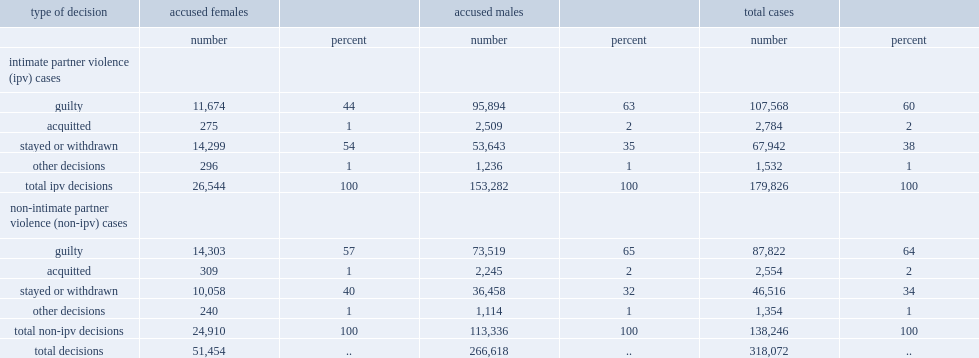Could you parse the entire table as a dict? {'header': ['type of decision', 'accused females', '', 'accused males', '', 'total cases', ''], 'rows': [['', 'number', 'percent', 'number', 'percent', 'number', 'percent'], ['intimate partner violence (ipv) cases', '', '', '', '', '', ''], ['guilty', '11,674', '44', '95,894', '63', '107,568', '60'], ['acquitted', '275', '1', '2,509', '2', '2,784', '2'], ['stayed or withdrawn', '14,299', '54', '53,643', '35', '67,942', '38'], ['other decisions', '296', '1', '1,236', '1', '1,532', '1'], ['total ipv decisions', '26,544', '100', '153,282', '100', '179,826', '100'], ['non-intimate partner violence (non-ipv) cases', '', '', '', '', '', ''], ['guilty', '14,303', '57', '73,519', '65', '87,822', '64'], ['acquitted', '309', '1', '2,245', '2', '2,554', '2'], ['stayed or withdrawn', '10,058', '40', '36,458', '32', '46,516', '34'], ['other decisions', '240', '1', '1,114', '1', '1,354', '1'], ['total non-ipv decisions', '24,910', '100', '113,336', '100', '138,246', '100'], ['total decisions', '51,454', '..', '266,618', '..', '318,072', '..']]} How many percentage points did non-ipv cases result in a guilty verdict? 64.0. How many percentage points did ipv cases result in a guilty verdict? 60.0. How many percentage points did ipv cases for accused males result in a guilty verdict? 63.0. How many percentage points did ipv cases for accused females result in a guilty verdict? 44.0. In non-ipv cases, how many percentage points have male accused been found guilty? 65.0. In non-ipv cases, how many percentage points have female accused been found guilty? 57.0. 